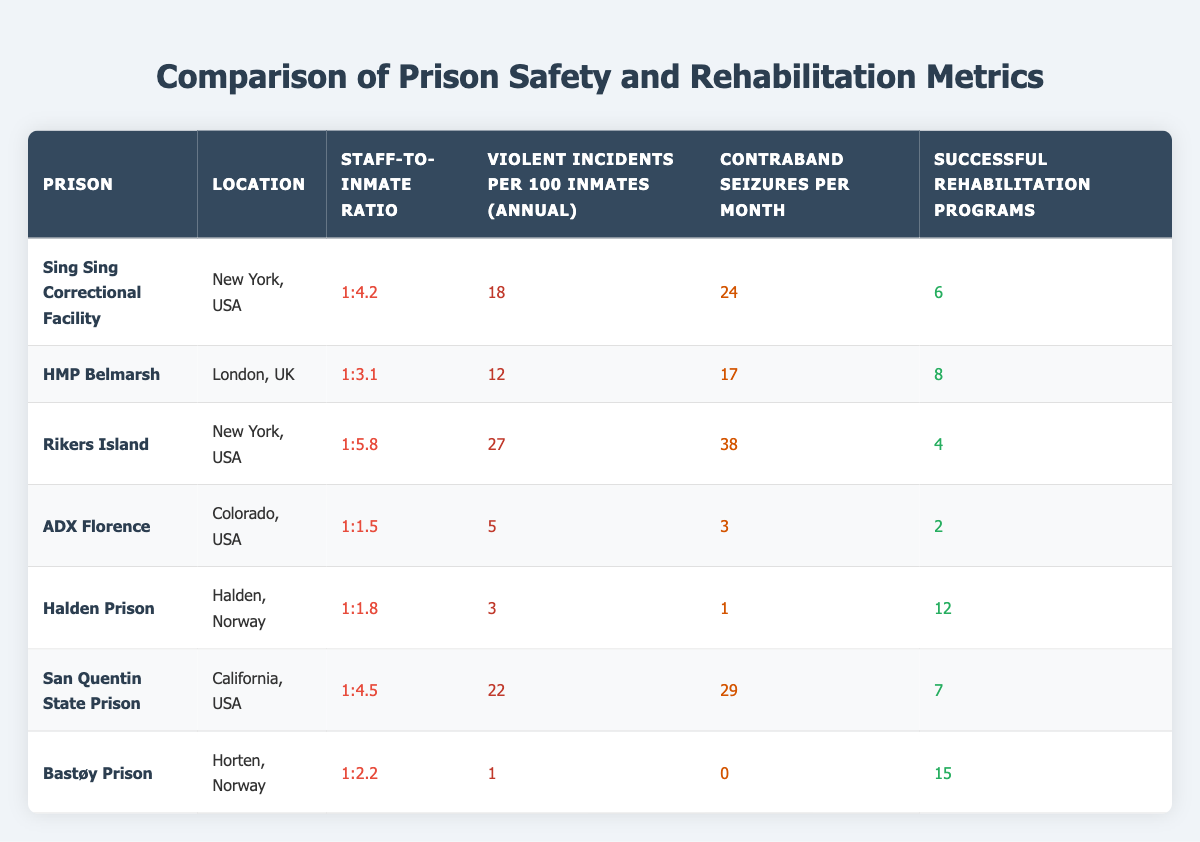What is the staff-to-inmate ratio at Halden Prison? Looking at the row for Halden Prison in the table, the staff-to-inmate ratio is clearly listed as 1:1.8.
Answer: 1:1.8 Which prison has the highest number of violent incidents per 100 inmates annually? By scanning the "Violent Incidents per 100 Inmates (Annual)" column, Rikers Island has the highest number with 27 incidents.
Answer: Rikers Island What is the average number of successful rehabilitation programs across all prisons listed? The number of successful rehabilitation programs is 6 (Sing Sing) + 8 (HMP Belmarsh) + 4 (Rikers Island) + 2 (ADX Florence) + 12 (Halden Prison) + 7 (San Quentin) + 15 (Bastøy) = 54. There are 7 prisions, so the average is 54/7 = 7.71, which rounds to approximately 7.7.
Answer: Approximately 7.7 Is it true that ADX Florence has fewer contraband seizures per month than Halden Prison? In the table, ADX Florence has 3 contraband seizures per month, whereas Halden Prison has 1. Therefore, it is false that ADX Florence has fewer than Halden.
Answer: No If we consider only the prisons with a staff-to-inmate ratio of 1:3 or better, which prison has the highest number of successful rehabilitation programs? Filtering for prisons with a ratio of 1:3 or better includes HMP Belmarsh (1:3.1), ADX Florence (1:1.5), Halden Prison (1:1.8), and Bastøy Prison (1:2.2). Among these, Halden Prison has the highest number of successful rehabilitation programs at 12.
Answer: Halden Prison 